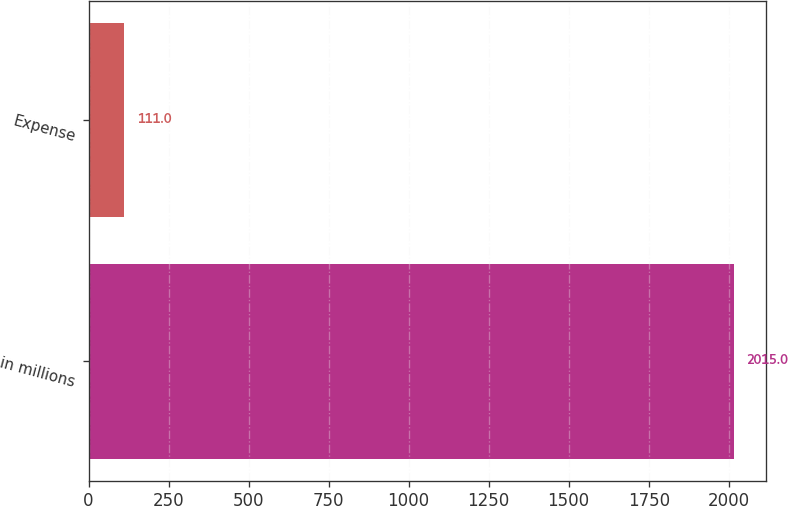<chart> <loc_0><loc_0><loc_500><loc_500><bar_chart><fcel>in millions<fcel>Expense<nl><fcel>2015<fcel>111<nl></chart> 